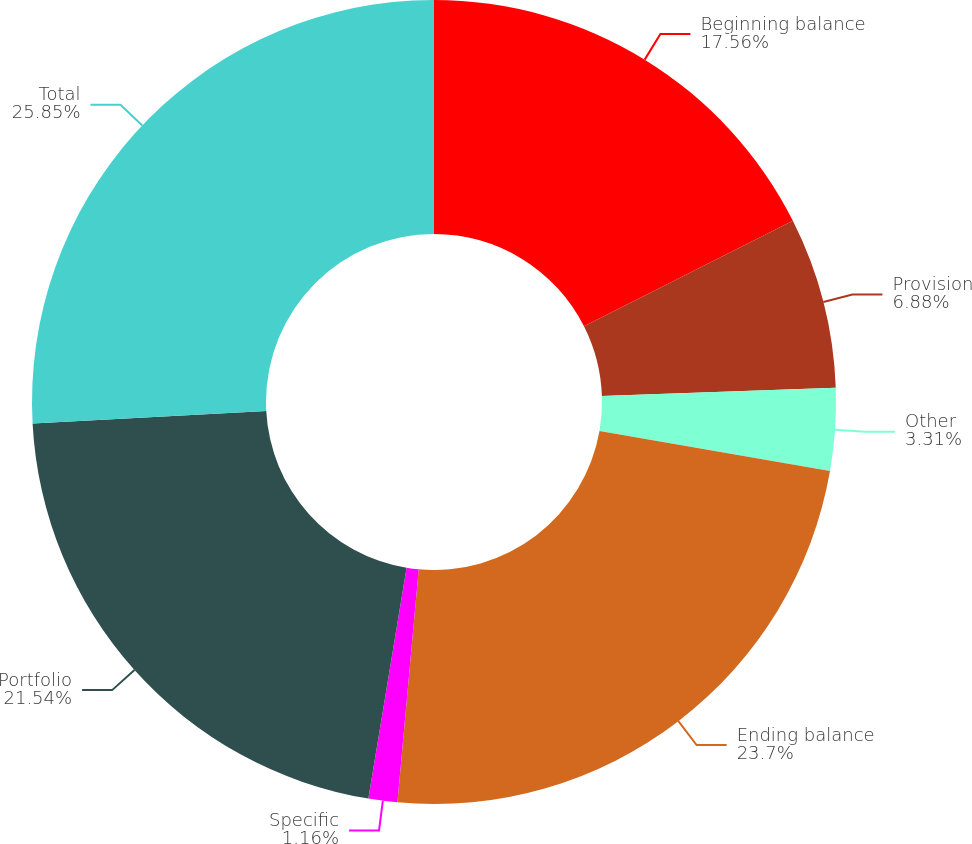Convert chart. <chart><loc_0><loc_0><loc_500><loc_500><pie_chart><fcel>Beginning balance<fcel>Provision<fcel>Other<fcel>Ending balance<fcel>Specific<fcel>Portfolio<fcel>Total<nl><fcel>17.56%<fcel>6.88%<fcel>3.31%<fcel>23.7%<fcel>1.16%<fcel>21.54%<fcel>25.85%<nl></chart> 